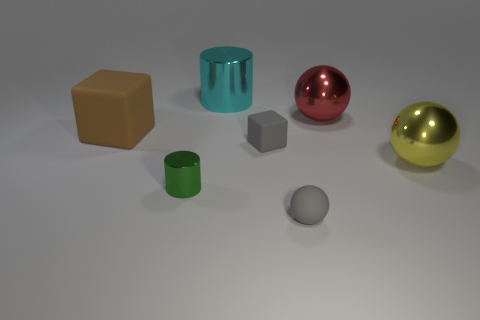There is a tiny rubber object that is behind the small gray matte sphere; does it have the same color as the ball that is in front of the green shiny cylinder?
Ensure brevity in your answer.  Yes. Are there any big brown cubes that have the same material as the big yellow object?
Give a very brief answer. No. There is a green cylinder that is the same size as the matte sphere; what is it made of?
Provide a succinct answer. Metal. Do the big red object and the big cyan cylinder have the same material?
Keep it short and to the point. Yes. What number of objects are big yellow objects or purple matte spheres?
Offer a very short reply. 1. The metallic thing left of the cyan shiny thing has what shape?
Provide a succinct answer. Cylinder. The large object that is made of the same material as the tiny sphere is what color?
Your answer should be very brief. Brown. What material is the tiny gray object that is the same shape as the yellow shiny thing?
Keep it short and to the point. Rubber. The cyan thing is what shape?
Make the answer very short. Cylinder. The thing that is on the left side of the big red sphere and on the right side of the gray matte block is made of what material?
Your answer should be very brief. Rubber. 